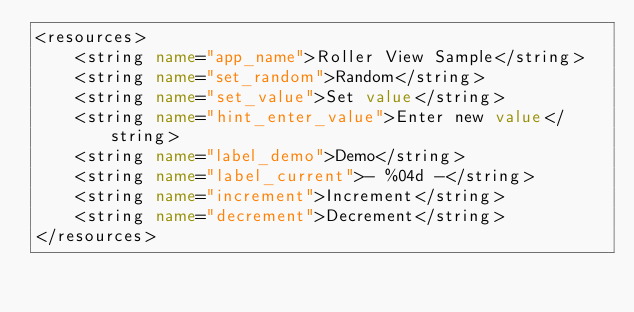<code> <loc_0><loc_0><loc_500><loc_500><_XML_><resources>
    <string name="app_name">Roller View Sample</string>
    <string name="set_random">Random</string>
    <string name="set_value">Set value</string>
    <string name="hint_enter_value">Enter new value</string>
    <string name="label_demo">Demo</string>
    <string name="label_current">- %04d -</string>
    <string name="increment">Increment</string>
    <string name="decrement">Decrement</string>
</resources>
</code> 